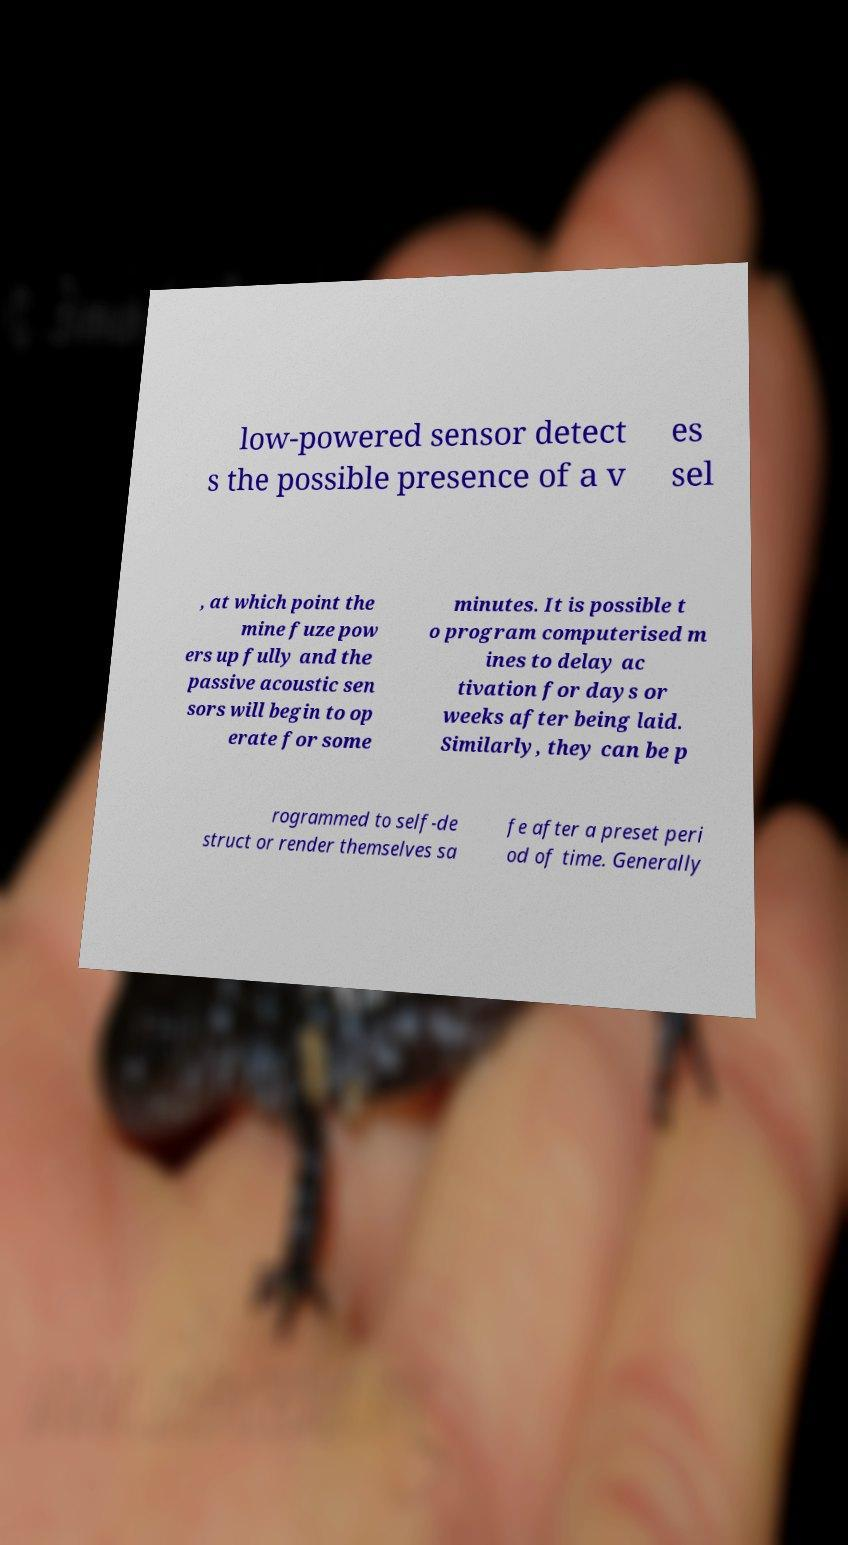Please identify and transcribe the text found in this image. low-powered sensor detect s the possible presence of a v es sel , at which point the mine fuze pow ers up fully and the passive acoustic sen sors will begin to op erate for some minutes. It is possible t o program computerised m ines to delay ac tivation for days or weeks after being laid. Similarly, they can be p rogrammed to self-de struct or render themselves sa fe after a preset peri od of time. Generally 